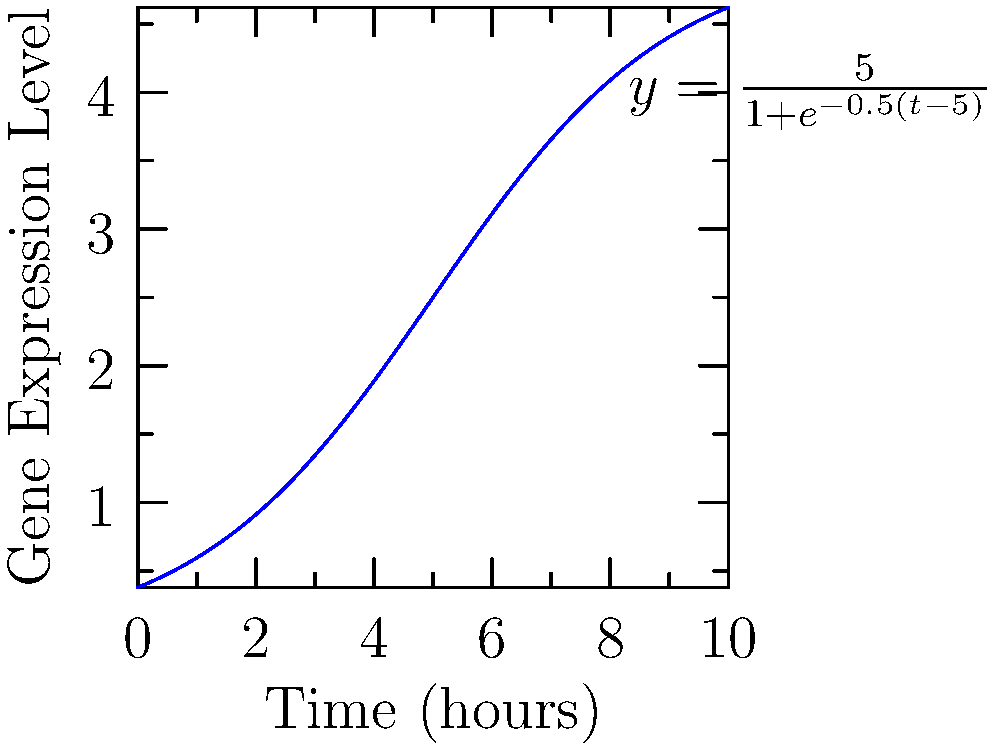The graph represents the level of gene expression over time for a specific gene after induction. The curve is described by the function $y = \frac{5}{1+e^{-0.5(t-5)}}$, where $y$ is the gene expression level and $t$ is time in hours. At what time point is the rate of change in gene expression the highest? To find the time point where the rate of change in gene expression is highest, we need to follow these steps:

1) The rate of change is represented by the derivative of the function. We need to find the maximum of this derivative.

2) Let's call our function $f(t) = \frac{5}{1+e^{-0.5(t-5)}}$

3) The derivative of this function is:
   $$f'(t) = \frac{5 \cdot 0.5 \cdot e^{-0.5(t-5)}}{(1+e^{-0.5(t-5)})^2}$$

4) To find the maximum of $f'(t)$, we need to find where its derivative equals zero:
   $$f''(t) = \frac{5 \cdot 0.5^2 \cdot e^{-0.5(t-5)} \cdot (e^{-0.5(t-5)} - 1)}{(1+e^{-0.5(t-5)})^3} = 0$$

5) This equation is satisfied when $e^{-0.5(t-5)} = 1$, which occurs when $t = 5$.

6) We can confirm this is a maximum by checking the sign of $f''(t)$ before and after $t=5$.

Therefore, the rate of change in gene expression is highest at $t = 5$ hours.
Answer: 5 hours 